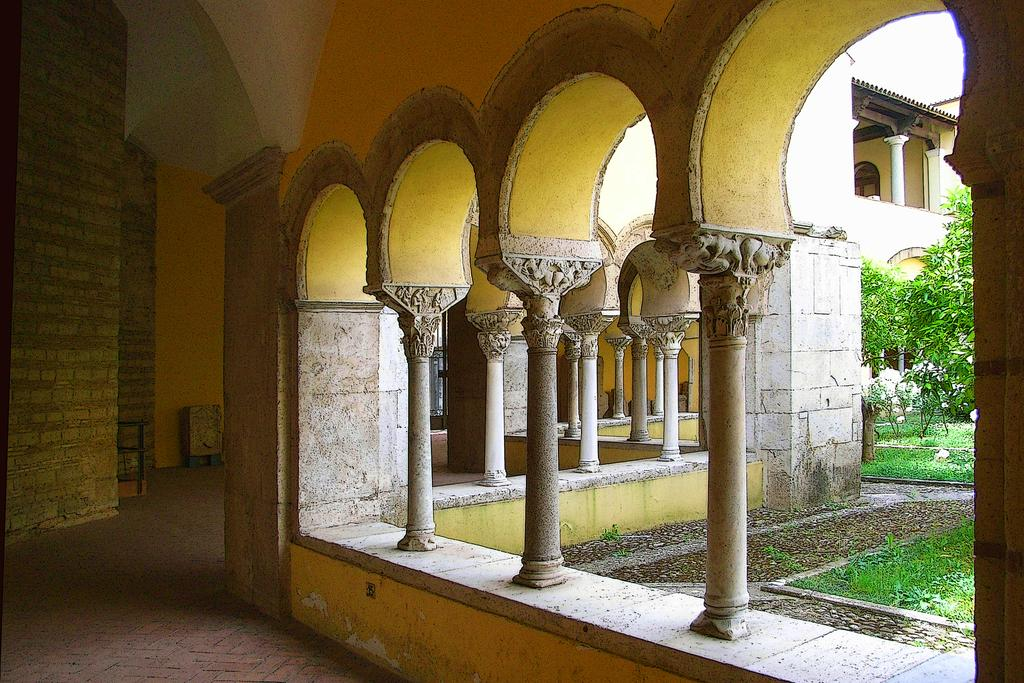What type of structure is present in the image? There is a building in the image. What can be seen on the right side of the image? Trees are visible on the right side of the image. What flavor of coat is the building wearing in the image? There is no coat present in the image, as it features a building and trees. 